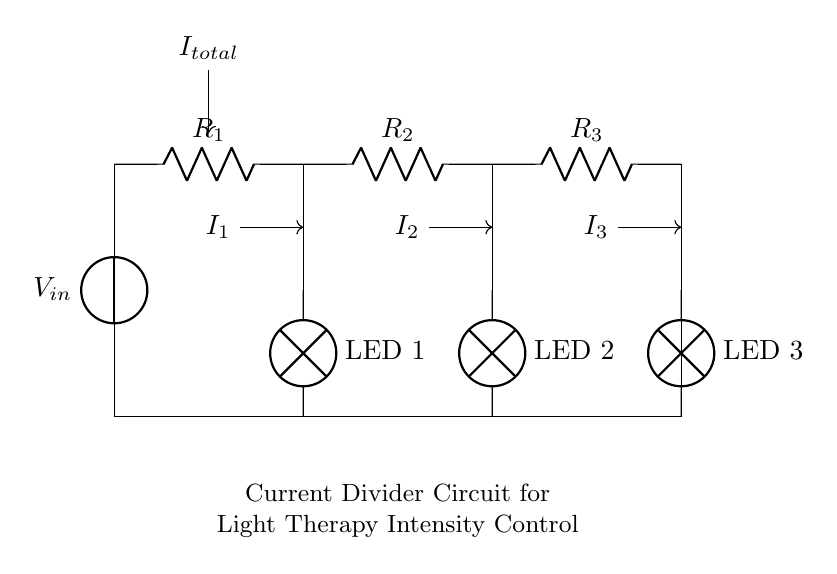What is the total current entering the circuit? The total current entering the circuit is represented as I_total at the top of the diagram, directed to the nodes of resistors R_1, R_2, and R_3.
Answer: I_total Which component is connected to R_1? The component connected to R_1 is LED 1, which is located directly beneath R_1, receiving the current passing through it.
Answer: LED 1 How many resistors are in the circuit? There are three resistors indicated in the diagram, labeled R_1, R_2, and R_3.
Answer: 3 What type of circuit configuration is shown here? The circuit configuration is a current divider since it splits the total current between multiple parallel branches (the resistors and the LEDs).
Answer: Current divider If the total current is 12 mA, what is the current through R_2? To determine the current through R_2, we note that in a current divider, the current splits inversely with respect to the resistance values. If R_1 < R_2 < R_3, then the current through R_2 will be less than I_total and can be further calculated if specific resistor values are provided.
Answer: Requires resistor values for calculation Which LED receives the greatest current? The LED with the lowest resistance will receive the greatest current. Thus, if LED currents are tied to their corresponding resistors, the LED connected to the smallest resistor receives the most current.
Answer: Depends on resistor values What happens if R_3 is reduced? Reducing R_3 decreases its resistance, which would cause more current to flow through LED 3 as per the current divider rule, increasing its brightness relative to the others; concurrently, the current through the other LEDs would decrease.
Answer: More current through LED 3 